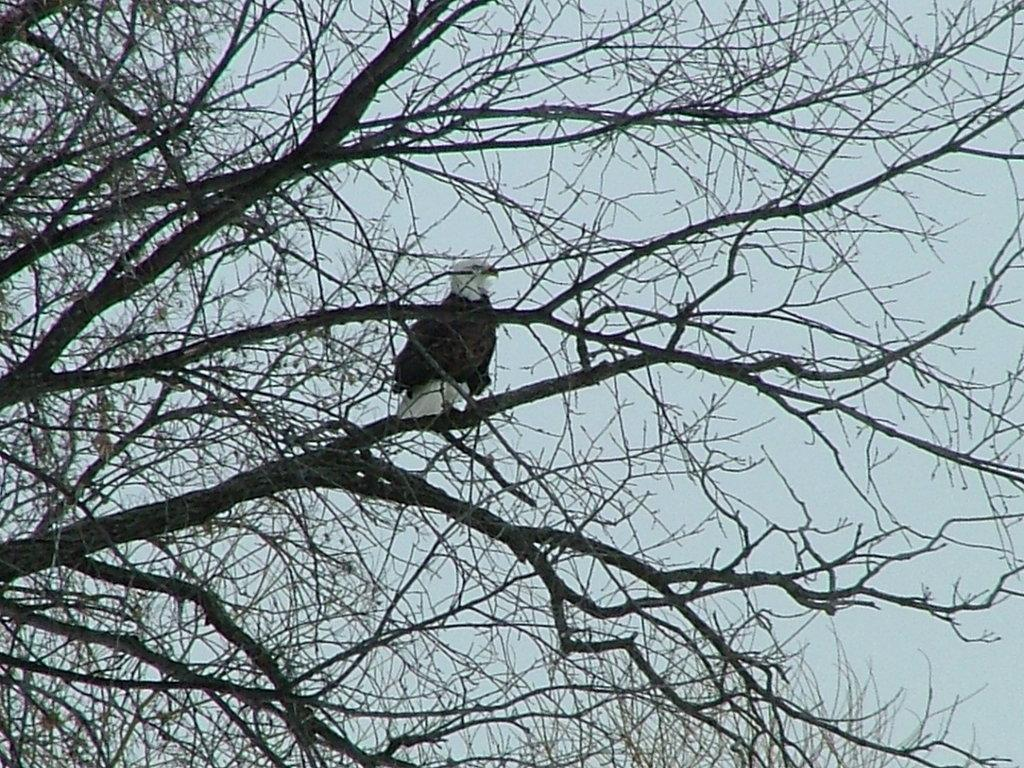What type of animal is in the image? There is a bird in the image. Where is the bird located? The bird is on the branch of a tree. What can be seen in the background of the image? The sky is visible in the background of the image. What is the bird's tendency to say good-bye in the image? There is no indication in the image that the bird is saying good-bye or has any specific tendency. 